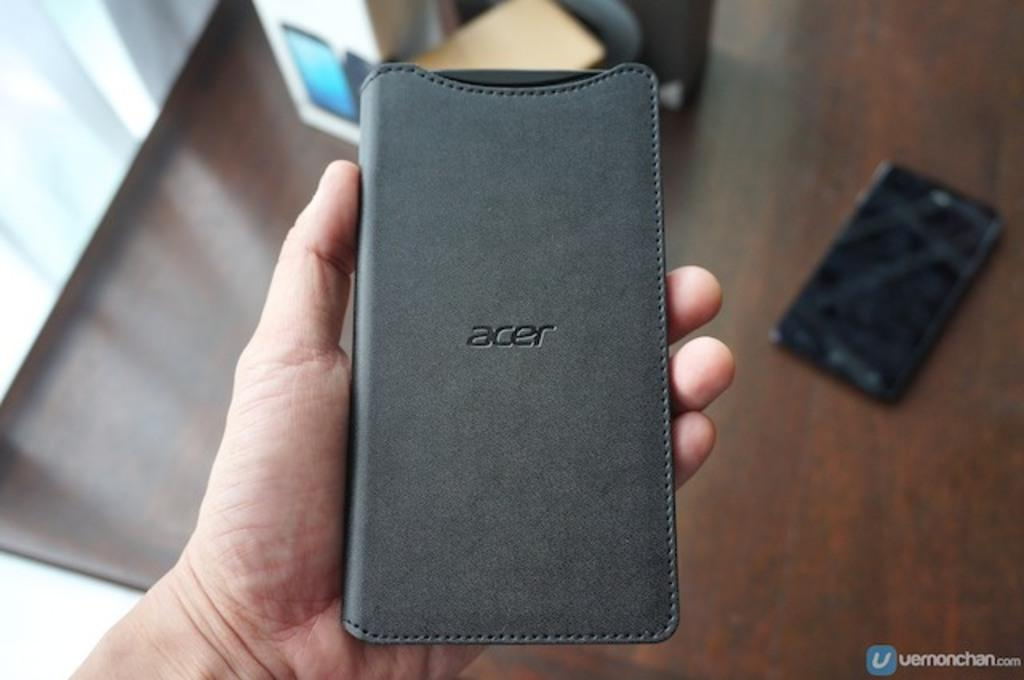Provide a one-sentence caption for the provided image. A hand holding a gray ACER phone case. 